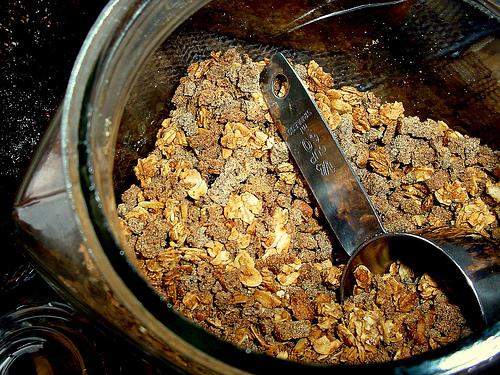<image>
Is there a measuring cup behind the granola? Yes. From this viewpoint, the measuring cup is positioned behind the granola, with the granola partially or fully occluding the measuring cup. 